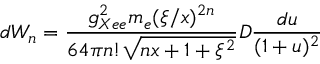<formula> <loc_0><loc_0><loc_500><loc_500>d W _ { n } = { \frac { g _ { X e e } ^ { 2 } m _ { e } ( \xi / x ) ^ { 2 n } } { 6 4 \pi n ! \sqrt { n x + 1 + \xi ^ { 2 } } } } D { \frac { d u } { ( 1 + u ) ^ { 2 } } }</formula> 